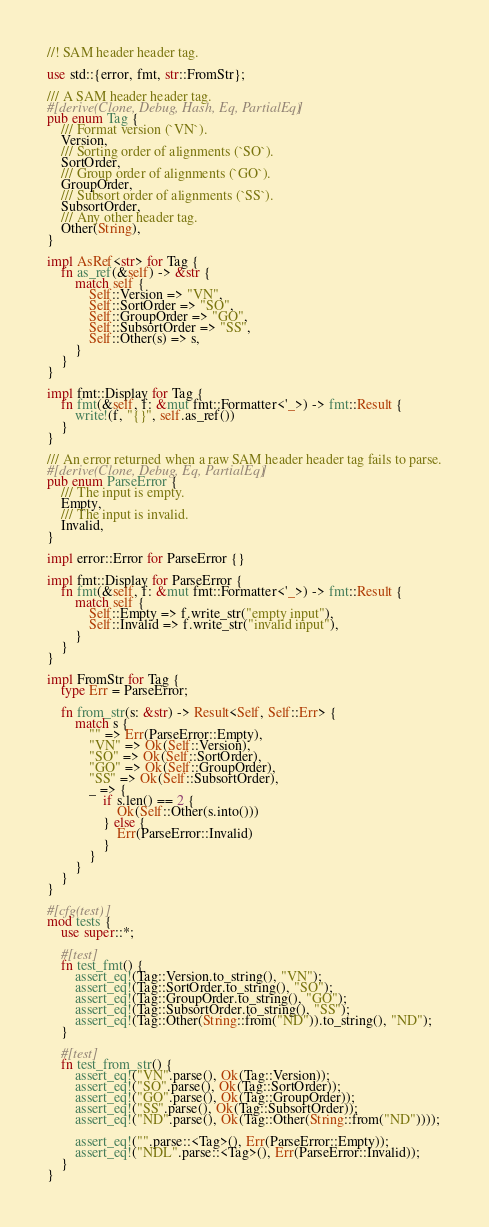<code> <loc_0><loc_0><loc_500><loc_500><_Rust_>//! SAM header header tag.

use std::{error, fmt, str::FromStr};

/// A SAM header header tag.
#[derive(Clone, Debug, Hash, Eq, PartialEq)]
pub enum Tag {
    /// Format version (`VN`).
    Version,
    /// Sorting order of alignments (`SO`).
    SortOrder,
    /// Group order of alignments (`GO`).
    GroupOrder,
    /// Subsort order of alignments (`SS`).
    SubsortOrder,
    /// Any other header tag.
    Other(String),
}

impl AsRef<str> for Tag {
    fn as_ref(&self) -> &str {
        match self {
            Self::Version => "VN",
            Self::SortOrder => "SO",
            Self::GroupOrder => "GO",
            Self::SubsortOrder => "SS",
            Self::Other(s) => s,
        }
    }
}

impl fmt::Display for Tag {
    fn fmt(&self, f: &mut fmt::Formatter<'_>) -> fmt::Result {
        write!(f, "{}", self.as_ref())
    }
}

/// An error returned when a raw SAM header header tag fails to parse.
#[derive(Clone, Debug, Eq, PartialEq)]
pub enum ParseError {
    /// The input is empty.
    Empty,
    /// The input is invalid.
    Invalid,
}

impl error::Error for ParseError {}

impl fmt::Display for ParseError {
    fn fmt(&self, f: &mut fmt::Formatter<'_>) -> fmt::Result {
        match self {
            Self::Empty => f.write_str("empty input"),
            Self::Invalid => f.write_str("invalid input"),
        }
    }
}

impl FromStr for Tag {
    type Err = ParseError;

    fn from_str(s: &str) -> Result<Self, Self::Err> {
        match s {
            "" => Err(ParseError::Empty),
            "VN" => Ok(Self::Version),
            "SO" => Ok(Self::SortOrder),
            "GO" => Ok(Self::GroupOrder),
            "SS" => Ok(Self::SubsortOrder),
            _ => {
                if s.len() == 2 {
                    Ok(Self::Other(s.into()))
                } else {
                    Err(ParseError::Invalid)
                }
            }
        }
    }
}

#[cfg(test)]
mod tests {
    use super::*;

    #[test]
    fn test_fmt() {
        assert_eq!(Tag::Version.to_string(), "VN");
        assert_eq!(Tag::SortOrder.to_string(), "SO");
        assert_eq!(Tag::GroupOrder.to_string(), "GO");
        assert_eq!(Tag::SubsortOrder.to_string(), "SS");
        assert_eq!(Tag::Other(String::from("ND")).to_string(), "ND");
    }

    #[test]
    fn test_from_str() {
        assert_eq!("VN".parse(), Ok(Tag::Version));
        assert_eq!("SO".parse(), Ok(Tag::SortOrder));
        assert_eq!("GO".parse(), Ok(Tag::GroupOrder));
        assert_eq!("SS".parse(), Ok(Tag::SubsortOrder));
        assert_eq!("ND".parse(), Ok(Tag::Other(String::from("ND"))));

        assert_eq!("".parse::<Tag>(), Err(ParseError::Empty));
        assert_eq!("NDL".parse::<Tag>(), Err(ParseError::Invalid));
    }
}
</code> 